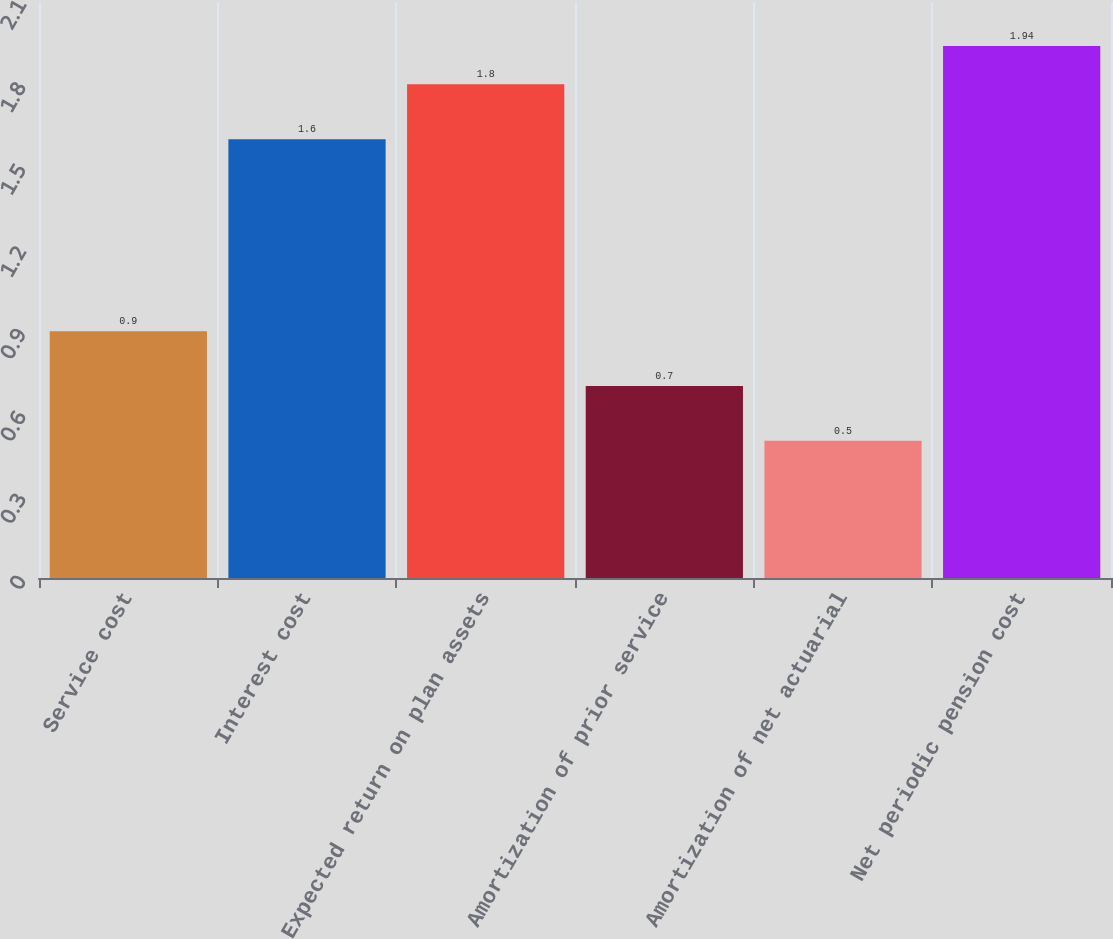Convert chart. <chart><loc_0><loc_0><loc_500><loc_500><bar_chart><fcel>Service cost<fcel>Interest cost<fcel>Expected return on plan assets<fcel>Amortization of prior service<fcel>Amortization of net actuarial<fcel>Net periodic pension cost<nl><fcel>0.9<fcel>1.6<fcel>1.8<fcel>0.7<fcel>0.5<fcel>1.94<nl></chart> 